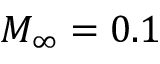<formula> <loc_0><loc_0><loc_500><loc_500>M _ { \infty } = 0 . 1</formula> 